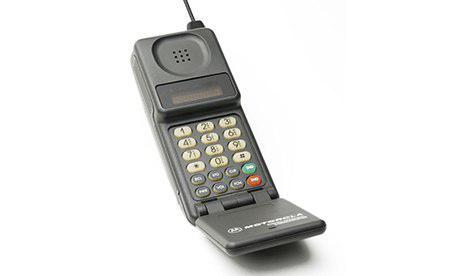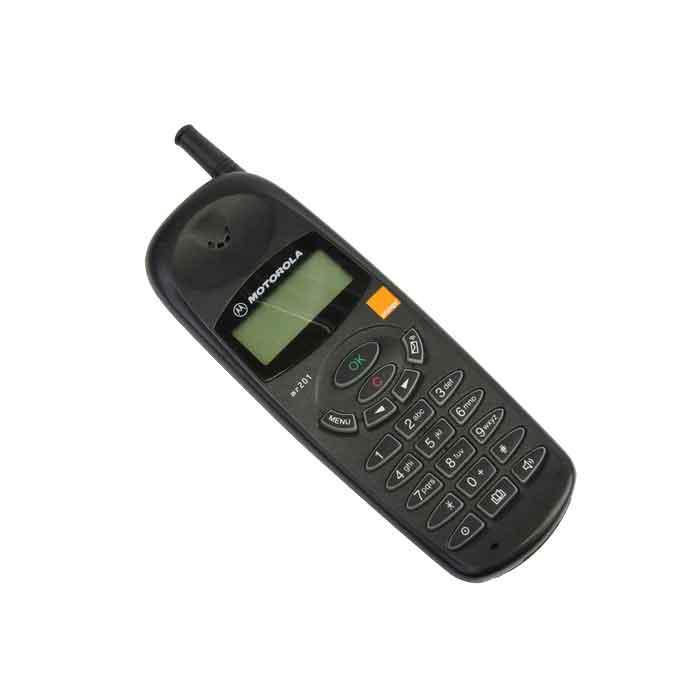The first image is the image on the left, the second image is the image on the right. For the images displayed, is the sentence "Three or fewer phones are visible." factually correct? Answer yes or no. Yes. The first image is the image on the left, the second image is the image on the right. Assess this claim about the two images: "At least one flip phone is visible in the right image.". Correct or not? Answer yes or no. No. 